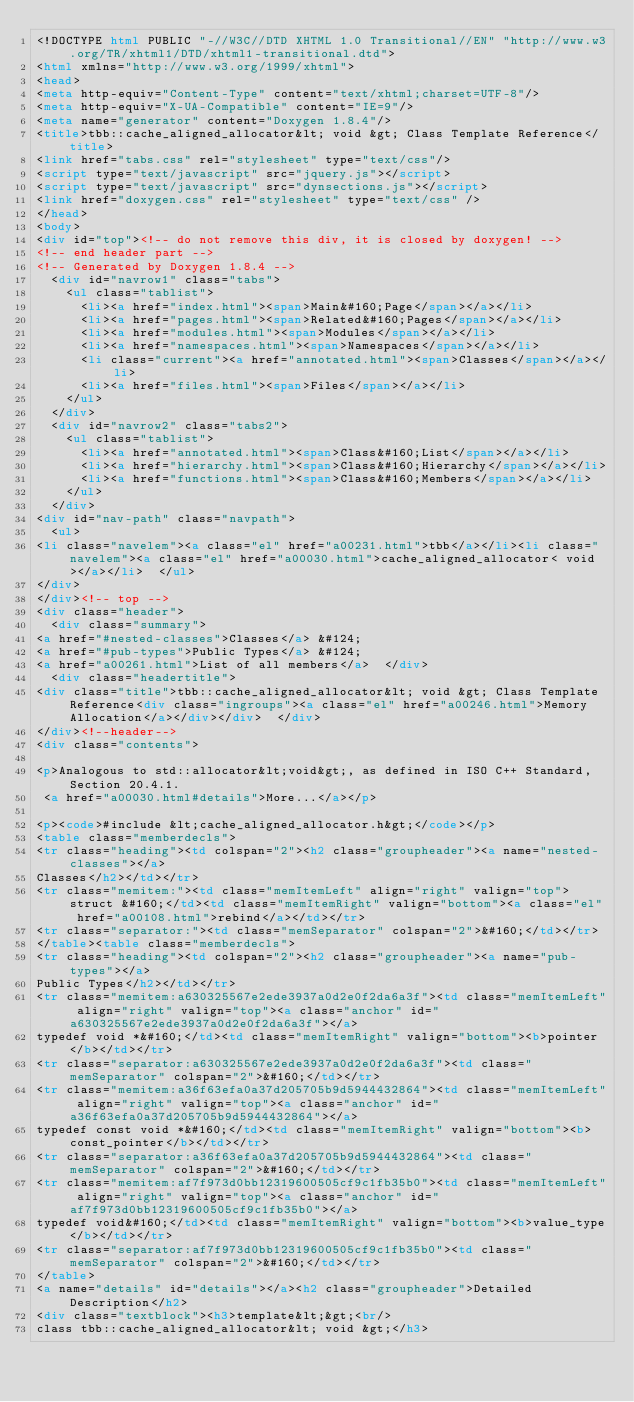<code> <loc_0><loc_0><loc_500><loc_500><_HTML_><!DOCTYPE html PUBLIC "-//W3C//DTD XHTML 1.0 Transitional//EN" "http://www.w3.org/TR/xhtml1/DTD/xhtml1-transitional.dtd">
<html xmlns="http://www.w3.org/1999/xhtml">
<head>
<meta http-equiv="Content-Type" content="text/xhtml;charset=UTF-8"/>
<meta http-equiv="X-UA-Compatible" content="IE=9"/>
<meta name="generator" content="Doxygen 1.8.4"/>
<title>tbb::cache_aligned_allocator&lt; void &gt; Class Template Reference</title>
<link href="tabs.css" rel="stylesheet" type="text/css"/>
<script type="text/javascript" src="jquery.js"></script>
<script type="text/javascript" src="dynsections.js"></script>
<link href="doxygen.css" rel="stylesheet" type="text/css" />
</head>
<body>
<div id="top"><!-- do not remove this div, it is closed by doxygen! -->
<!-- end header part -->
<!-- Generated by Doxygen 1.8.4 -->
  <div id="navrow1" class="tabs">
    <ul class="tablist">
      <li><a href="index.html"><span>Main&#160;Page</span></a></li>
      <li><a href="pages.html"><span>Related&#160;Pages</span></a></li>
      <li><a href="modules.html"><span>Modules</span></a></li>
      <li><a href="namespaces.html"><span>Namespaces</span></a></li>
      <li class="current"><a href="annotated.html"><span>Classes</span></a></li>
      <li><a href="files.html"><span>Files</span></a></li>
    </ul>
  </div>
  <div id="navrow2" class="tabs2">
    <ul class="tablist">
      <li><a href="annotated.html"><span>Class&#160;List</span></a></li>
      <li><a href="hierarchy.html"><span>Class&#160;Hierarchy</span></a></li>
      <li><a href="functions.html"><span>Class&#160;Members</span></a></li>
    </ul>
  </div>
<div id="nav-path" class="navpath">
  <ul>
<li class="navelem"><a class="el" href="a00231.html">tbb</a></li><li class="navelem"><a class="el" href="a00030.html">cache_aligned_allocator< void ></a></li>  </ul>
</div>
</div><!-- top -->
<div class="header">
  <div class="summary">
<a href="#nested-classes">Classes</a> &#124;
<a href="#pub-types">Public Types</a> &#124;
<a href="a00261.html">List of all members</a>  </div>
  <div class="headertitle">
<div class="title">tbb::cache_aligned_allocator&lt; void &gt; Class Template Reference<div class="ingroups"><a class="el" href="a00246.html">Memory Allocation</a></div></div>  </div>
</div><!--header-->
<div class="contents">

<p>Analogous to std::allocator&lt;void&gt;, as defined in ISO C++ Standard, Section 20.4.1.  
 <a href="a00030.html#details">More...</a></p>

<p><code>#include &lt;cache_aligned_allocator.h&gt;</code></p>
<table class="memberdecls">
<tr class="heading"><td colspan="2"><h2 class="groupheader"><a name="nested-classes"></a>
Classes</h2></td></tr>
<tr class="memitem:"><td class="memItemLeft" align="right" valign="top">struct &#160;</td><td class="memItemRight" valign="bottom"><a class="el" href="a00108.html">rebind</a></td></tr>
<tr class="separator:"><td class="memSeparator" colspan="2">&#160;</td></tr>
</table><table class="memberdecls">
<tr class="heading"><td colspan="2"><h2 class="groupheader"><a name="pub-types"></a>
Public Types</h2></td></tr>
<tr class="memitem:a630325567e2ede3937a0d2e0f2da6a3f"><td class="memItemLeft" align="right" valign="top"><a class="anchor" id="a630325567e2ede3937a0d2e0f2da6a3f"></a>
typedef void *&#160;</td><td class="memItemRight" valign="bottom"><b>pointer</b></td></tr>
<tr class="separator:a630325567e2ede3937a0d2e0f2da6a3f"><td class="memSeparator" colspan="2">&#160;</td></tr>
<tr class="memitem:a36f63efa0a37d205705b9d5944432864"><td class="memItemLeft" align="right" valign="top"><a class="anchor" id="a36f63efa0a37d205705b9d5944432864"></a>
typedef const void *&#160;</td><td class="memItemRight" valign="bottom"><b>const_pointer</b></td></tr>
<tr class="separator:a36f63efa0a37d205705b9d5944432864"><td class="memSeparator" colspan="2">&#160;</td></tr>
<tr class="memitem:af7f973d0bb12319600505cf9c1fb35b0"><td class="memItemLeft" align="right" valign="top"><a class="anchor" id="af7f973d0bb12319600505cf9c1fb35b0"></a>
typedef void&#160;</td><td class="memItemRight" valign="bottom"><b>value_type</b></td></tr>
<tr class="separator:af7f973d0bb12319600505cf9c1fb35b0"><td class="memSeparator" colspan="2">&#160;</td></tr>
</table>
<a name="details" id="details"></a><h2 class="groupheader">Detailed Description</h2>
<div class="textblock"><h3>template&lt;&gt;<br/>
class tbb::cache_aligned_allocator&lt; void &gt;</h3>
</code> 